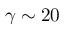Convert formula to latex. <formula><loc_0><loc_0><loc_500><loc_500>\gamma \sim 2 0</formula> 